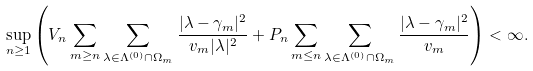Convert formula to latex. <formula><loc_0><loc_0><loc_500><loc_500>\sup _ { n \geq 1 } \left ( V _ { n } \sum _ { m \geq n } \sum _ { \lambda \in \Lambda ^ { ( 0 ) } \cap \Omega _ { m } } \frac { | \lambda - \gamma _ { m } | ^ { 2 } } { v _ { m } | \lambda | ^ { 2 } } + P _ { n } \sum _ { m \leq n } \sum _ { \lambda \in \Lambda ^ { ( 0 ) } \cap \Omega _ { m } } \frac { | \lambda - \gamma _ { m } | ^ { 2 } } { v _ { m } } \right ) < \infty .</formula> 